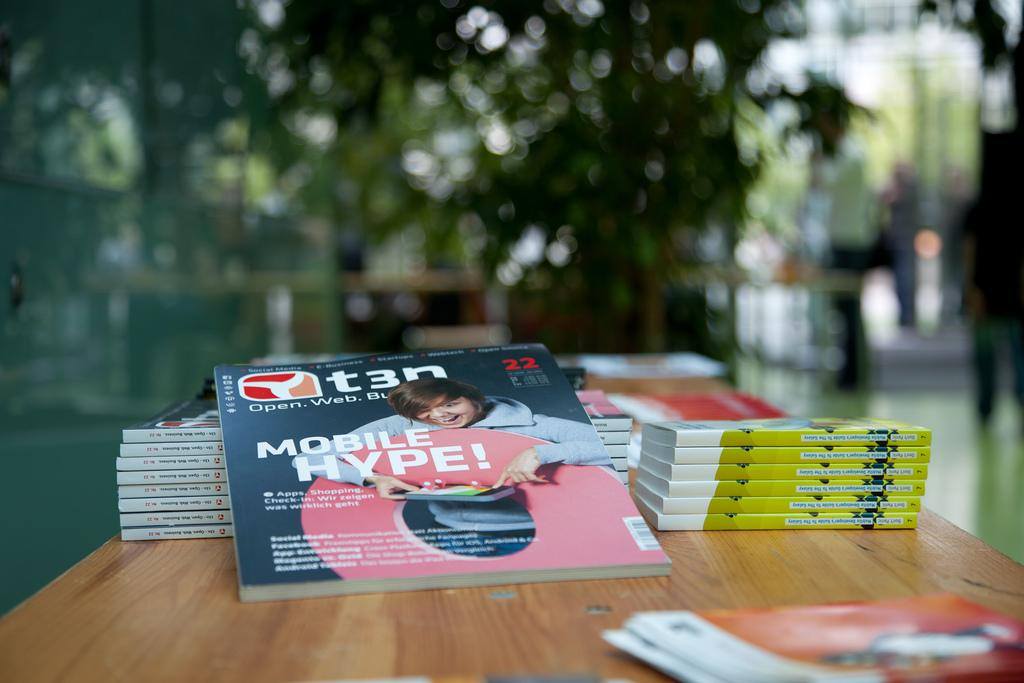<image>
Present a compact description of the photo's key features. T3n book about mobile hype for social media and business. 